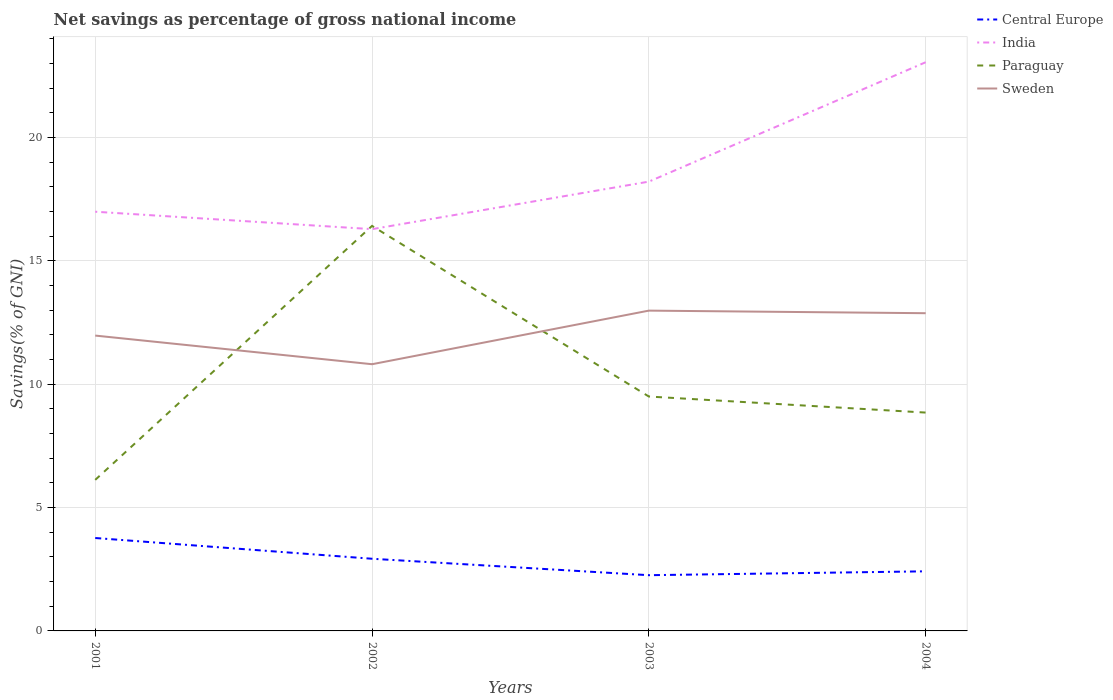How many different coloured lines are there?
Your answer should be very brief. 4. Is the number of lines equal to the number of legend labels?
Offer a terse response. Yes. Across all years, what is the maximum total savings in Sweden?
Offer a very short reply. 10.81. In which year was the total savings in Paraguay maximum?
Make the answer very short. 2001. What is the total total savings in India in the graph?
Your answer should be very brief. -6.76. What is the difference between the highest and the second highest total savings in Paraguay?
Make the answer very short. 10.29. Is the total savings in India strictly greater than the total savings in Paraguay over the years?
Keep it short and to the point. No. How many lines are there?
Make the answer very short. 4. How many years are there in the graph?
Keep it short and to the point. 4. How are the legend labels stacked?
Provide a short and direct response. Vertical. What is the title of the graph?
Offer a very short reply. Net savings as percentage of gross national income. What is the label or title of the X-axis?
Offer a terse response. Years. What is the label or title of the Y-axis?
Offer a very short reply. Savings(% of GNI). What is the Savings(% of GNI) of Central Europe in 2001?
Make the answer very short. 3.77. What is the Savings(% of GNI) in India in 2001?
Give a very brief answer. 16.99. What is the Savings(% of GNI) in Paraguay in 2001?
Provide a short and direct response. 6.12. What is the Savings(% of GNI) of Sweden in 2001?
Give a very brief answer. 11.97. What is the Savings(% of GNI) in Central Europe in 2002?
Provide a short and direct response. 2.92. What is the Savings(% of GNI) in India in 2002?
Your answer should be compact. 16.28. What is the Savings(% of GNI) of Paraguay in 2002?
Make the answer very short. 16.41. What is the Savings(% of GNI) of Sweden in 2002?
Your answer should be very brief. 10.81. What is the Savings(% of GNI) of Central Europe in 2003?
Provide a short and direct response. 2.26. What is the Savings(% of GNI) of India in 2003?
Provide a short and direct response. 18.21. What is the Savings(% of GNI) in Paraguay in 2003?
Keep it short and to the point. 9.5. What is the Savings(% of GNI) in Sweden in 2003?
Offer a terse response. 12.98. What is the Savings(% of GNI) in Central Europe in 2004?
Provide a succinct answer. 2.42. What is the Savings(% of GNI) of India in 2004?
Offer a terse response. 23.04. What is the Savings(% of GNI) of Paraguay in 2004?
Your response must be concise. 8.85. What is the Savings(% of GNI) in Sweden in 2004?
Keep it short and to the point. 12.87. Across all years, what is the maximum Savings(% of GNI) in Central Europe?
Provide a succinct answer. 3.77. Across all years, what is the maximum Savings(% of GNI) of India?
Make the answer very short. 23.04. Across all years, what is the maximum Savings(% of GNI) of Paraguay?
Provide a short and direct response. 16.41. Across all years, what is the maximum Savings(% of GNI) of Sweden?
Provide a short and direct response. 12.98. Across all years, what is the minimum Savings(% of GNI) in Central Europe?
Your response must be concise. 2.26. Across all years, what is the minimum Savings(% of GNI) of India?
Make the answer very short. 16.28. Across all years, what is the minimum Savings(% of GNI) in Paraguay?
Your response must be concise. 6.12. Across all years, what is the minimum Savings(% of GNI) in Sweden?
Ensure brevity in your answer.  10.81. What is the total Savings(% of GNI) of Central Europe in the graph?
Offer a very short reply. 11.36. What is the total Savings(% of GNI) in India in the graph?
Your answer should be compact. 74.52. What is the total Savings(% of GNI) in Paraguay in the graph?
Your answer should be very brief. 40.88. What is the total Savings(% of GNI) in Sweden in the graph?
Offer a terse response. 48.63. What is the difference between the Savings(% of GNI) of Central Europe in 2001 and that in 2002?
Ensure brevity in your answer.  0.84. What is the difference between the Savings(% of GNI) in India in 2001 and that in 2002?
Provide a short and direct response. 0.71. What is the difference between the Savings(% of GNI) of Paraguay in 2001 and that in 2002?
Provide a succinct answer. -10.29. What is the difference between the Savings(% of GNI) in Sweden in 2001 and that in 2002?
Keep it short and to the point. 1.16. What is the difference between the Savings(% of GNI) in Central Europe in 2001 and that in 2003?
Your response must be concise. 1.51. What is the difference between the Savings(% of GNI) in India in 2001 and that in 2003?
Provide a succinct answer. -1.22. What is the difference between the Savings(% of GNI) of Paraguay in 2001 and that in 2003?
Offer a very short reply. -3.38. What is the difference between the Savings(% of GNI) of Sweden in 2001 and that in 2003?
Your answer should be compact. -1.01. What is the difference between the Savings(% of GNI) in Central Europe in 2001 and that in 2004?
Give a very brief answer. 1.35. What is the difference between the Savings(% of GNI) in India in 2001 and that in 2004?
Make the answer very short. -6.06. What is the difference between the Savings(% of GNI) of Paraguay in 2001 and that in 2004?
Provide a succinct answer. -2.73. What is the difference between the Savings(% of GNI) in Sweden in 2001 and that in 2004?
Make the answer very short. -0.91. What is the difference between the Savings(% of GNI) in Central Europe in 2002 and that in 2003?
Keep it short and to the point. 0.67. What is the difference between the Savings(% of GNI) of India in 2002 and that in 2003?
Your response must be concise. -1.93. What is the difference between the Savings(% of GNI) in Paraguay in 2002 and that in 2003?
Offer a terse response. 6.91. What is the difference between the Savings(% of GNI) in Sweden in 2002 and that in 2003?
Provide a short and direct response. -2.17. What is the difference between the Savings(% of GNI) in Central Europe in 2002 and that in 2004?
Provide a succinct answer. 0.51. What is the difference between the Savings(% of GNI) in India in 2002 and that in 2004?
Give a very brief answer. -6.76. What is the difference between the Savings(% of GNI) of Paraguay in 2002 and that in 2004?
Make the answer very short. 7.56. What is the difference between the Savings(% of GNI) of Sweden in 2002 and that in 2004?
Offer a very short reply. -2.07. What is the difference between the Savings(% of GNI) in Central Europe in 2003 and that in 2004?
Your response must be concise. -0.16. What is the difference between the Savings(% of GNI) in India in 2003 and that in 2004?
Offer a very short reply. -4.84. What is the difference between the Savings(% of GNI) of Paraguay in 2003 and that in 2004?
Offer a terse response. 0.65. What is the difference between the Savings(% of GNI) in Sweden in 2003 and that in 2004?
Your answer should be very brief. 0.1. What is the difference between the Savings(% of GNI) in Central Europe in 2001 and the Savings(% of GNI) in India in 2002?
Ensure brevity in your answer.  -12.52. What is the difference between the Savings(% of GNI) in Central Europe in 2001 and the Savings(% of GNI) in Paraguay in 2002?
Your response must be concise. -12.65. What is the difference between the Savings(% of GNI) of Central Europe in 2001 and the Savings(% of GNI) of Sweden in 2002?
Keep it short and to the point. -7.04. What is the difference between the Savings(% of GNI) in India in 2001 and the Savings(% of GNI) in Paraguay in 2002?
Ensure brevity in your answer.  0.57. What is the difference between the Savings(% of GNI) of India in 2001 and the Savings(% of GNI) of Sweden in 2002?
Make the answer very short. 6.18. What is the difference between the Savings(% of GNI) in Paraguay in 2001 and the Savings(% of GNI) in Sweden in 2002?
Your answer should be compact. -4.69. What is the difference between the Savings(% of GNI) of Central Europe in 2001 and the Savings(% of GNI) of India in 2003?
Offer a very short reply. -14.44. What is the difference between the Savings(% of GNI) of Central Europe in 2001 and the Savings(% of GNI) of Paraguay in 2003?
Offer a terse response. -5.73. What is the difference between the Savings(% of GNI) in Central Europe in 2001 and the Savings(% of GNI) in Sweden in 2003?
Provide a succinct answer. -9.21. What is the difference between the Savings(% of GNI) in India in 2001 and the Savings(% of GNI) in Paraguay in 2003?
Ensure brevity in your answer.  7.49. What is the difference between the Savings(% of GNI) in India in 2001 and the Savings(% of GNI) in Sweden in 2003?
Give a very brief answer. 4.01. What is the difference between the Savings(% of GNI) of Paraguay in 2001 and the Savings(% of GNI) of Sweden in 2003?
Offer a terse response. -6.86. What is the difference between the Savings(% of GNI) in Central Europe in 2001 and the Savings(% of GNI) in India in 2004?
Your answer should be very brief. -19.28. What is the difference between the Savings(% of GNI) in Central Europe in 2001 and the Savings(% of GNI) in Paraguay in 2004?
Provide a short and direct response. -5.08. What is the difference between the Savings(% of GNI) of Central Europe in 2001 and the Savings(% of GNI) of Sweden in 2004?
Provide a short and direct response. -9.11. What is the difference between the Savings(% of GNI) in India in 2001 and the Savings(% of GNI) in Paraguay in 2004?
Keep it short and to the point. 8.14. What is the difference between the Savings(% of GNI) in India in 2001 and the Savings(% of GNI) in Sweden in 2004?
Ensure brevity in your answer.  4.11. What is the difference between the Savings(% of GNI) of Paraguay in 2001 and the Savings(% of GNI) of Sweden in 2004?
Offer a very short reply. -6.75. What is the difference between the Savings(% of GNI) in Central Europe in 2002 and the Savings(% of GNI) in India in 2003?
Ensure brevity in your answer.  -15.28. What is the difference between the Savings(% of GNI) in Central Europe in 2002 and the Savings(% of GNI) in Paraguay in 2003?
Keep it short and to the point. -6.57. What is the difference between the Savings(% of GNI) in Central Europe in 2002 and the Savings(% of GNI) in Sweden in 2003?
Keep it short and to the point. -10.05. What is the difference between the Savings(% of GNI) of India in 2002 and the Savings(% of GNI) of Paraguay in 2003?
Provide a succinct answer. 6.78. What is the difference between the Savings(% of GNI) of India in 2002 and the Savings(% of GNI) of Sweden in 2003?
Provide a short and direct response. 3.3. What is the difference between the Savings(% of GNI) of Paraguay in 2002 and the Savings(% of GNI) of Sweden in 2003?
Provide a short and direct response. 3.43. What is the difference between the Savings(% of GNI) in Central Europe in 2002 and the Savings(% of GNI) in India in 2004?
Your answer should be very brief. -20.12. What is the difference between the Savings(% of GNI) in Central Europe in 2002 and the Savings(% of GNI) in Paraguay in 2004?
Offer a very short reply. -5.92. What is the difference between the Savings(% of GNI) of Central Europe in 2002 and the Savings(% of GNI) of Sweden in 2004?
Offer a very short reply. -9.95. What is the difference between the Savings(% of GNI) in India in 2002 and the Savings(% of GNI) in Paraguay in 2004?
Your response must be concise. 7.43. What is the difference between the Savings(% of GNI) in India in 2002 and the Savings(% of GNI) in Sweden in 2004?
Your response must be concise. 3.41. What is the difference between the Savings(% of GNI) of Paraguay in 2002 and the Savings(% of GNI) of Sweden in 2004?
Ensure brevity in your answer.  3.54. What is the difference between the Savings(% of GNI) of Central Europe in 2003 and the Savings(% of GNI) of India in 2004?
Keep it short and to the point. -20.79. What is the difference between the Savings(% of GNI) of Central Europe in 2003 and the Savings(% of GNI) of Paraguay in 2004?
Offer a very short reply. -6.59. What is the difference between the Savings(% of GNI) in Central Europe in 2003 and the Savings(% of GNI) in Sweden in 2004?
Keep it short and to the point. -10.62. What is the difference between the Savings(% of GNI) in India in 2003 and the Savings(% of GNI) in Paraguay in 2004?
Provide a succinct answer. 9.36. What is the difference between the Savings(% of GNI) in India in 2003 and the Savings(% of GNI) in Sweden in 2004?
Give a very brief answer. 5.33. What is the difference between the Savings(% of GNI) in Paraguay in 2003 and the Savings(% of GNI) in Sweden in 2004?
Make the answer very short. -3.38. What is the average Savings(% of GNI) of Central Europe per year?
Offer a very short reply. 2.84. What is the average Savings(% of GNI) in India per year?
Keep it short and to the point. 18.63. What is the average Savings(% of GNI) in Paraguay per year?
Your answer should be very brief. 10.22. What is the average Savings(% of GNI) of Sweden per year?
Make the answer very short. 12.16. In the year 2001, what is the difference between the Savings(% of GNI) of Central Europe and Savings(% of GNI) of India?
Keep it short and to the point. -13.22. In the year 2001, what is the difference between the Savings(% of GNI) in Central Europe and Savings(% of GNI) in Paraguay?
Your response must be concise. -2.36. In the year 2001, what is the difference between the Savings(% of GNI) of Central Europe and Savings(% of GNI) of Sweden?
Ensure brevity in your answer.  -8.2. In the year 2001, what is the difference between the Savings(% of GNI) in India and Savings(% of GNI) in Paraguay?
Ensure brevity in your answer.  10.87. In the year 2001, what is the difference between the Savings(% of GNI) of India and Savings(% of GNI) of Sweden?
Ensure brevity in your answer.  5.02. In the year 2001, what is the difference between the Savings(% of GNI) of Paraguay and Savings(% of GNI) of Sweden?
Provide a succinct answer. -5.85. In the year 2002, what is the difference between the Savings(% of GNI) in Central Europe and Savings(% of GNI) in India?
Your answer should be very brief. -13.36. In the year 2002, what is the difference between the Savings(% of GNI) in Central Europe and Savings(% of GNI) in Paraguay?
Keep it short and to the point. -13.49. In the year 2002, what is the difference between the Savings(% of GNI) of Central Europe and Savings(% of GNI) of Sweden?
Keep it short and to the point. -7.88. In the year 2002, what is the difference between the Savings(% of GNI) of India and Savings(% of GNI) of Paraguay?
Your response must be concise. -0.13. In the year 2002, what is the difference between the Savings(% of GNI) of India and Savings(% of GNI) of Sweden?
Offer a very short reply. 5.47. In the year 2002, what is the difference between the Savings(% of GNI) of Paraguay and Savings(% of GNI) of Sweden?
Offer a very short reply. 5.61. In the year 2003, what is the difference between the Savings(% of GNI) in Central Europe and Savings(% of GNI) in India?
Offer a terse response. -15.95. In the year 2003, what is the difference between the Savings(% of GNI) of Central Europe and Savings(% of GNI) of Paraguay?
Provide a short and direct response. -7.24. In the year 2003, what is the difference between the Savings(% of GNI) of Central Europe and Savings(% of GNI) of Sweden?
Give a very brief answer. -10.72. In the year 2003, what is the difference between the Savings(% of GNI) of India and Savings(% of GNI) of Paraguay?
Your answer should be very brief. 8.71. In the year 2003, what is the difference between the Savings(% of GNI) of India and Savings(% of GNI) of Sweden?
Make the answer very short. 5.23. In the year 2003, what is the difference between the Savings(% of GNI) of Paraguay and Savings(% of GNI) of Sweden?
Provide a short and direct response. -3.48. In the year 2004, what is the difference between the Savings(% of GNI) in Central Europe and Savings(% of GNI) in India?
Make the answer very short. -20.63. In the year 2004, what is the difference between the Savings(% of GNI) of Central Europe and Savings(% of GNI) of Paraguay?
Give a very brief answer. -6.43. In the year 2004, what is the difference between the Savings(% of GNI) in Central Europe and Savings(% of GNI) in Sweden?
Your response must be concise. -10.46. In the year 2004, what is the difference between the Savings(% of GNI) of India and Savings(% of GNI) of Paraguay?
Give a very brief answer. 14.2. In the year 2004, what is the difference between the Savings(% of GNI) in India and Savings(% of GNI) in Sweden?
Give a very brief answer. 10.17. In the year 2004, what is the difference between the Savings(% of GNI) in Paraguay and Savings(% of GNI) in Sweden?
Provide a succinct answer. -4.03. What is the ratio of the Savings(% of GNI) of Central Europe in 2001 to that in 2002?
Your answer should be very brief. 1.29. What is the ratio of the Savings(% of GNI) of India in 2001 to that in 2002?
Provide a short and direct response. 1.04. What is the ratio of the Savings(% of GNI) in Paraguay in 2001 to that in 2002?
Provide a short and direct response. 0.37. What is the ratio of the Savings(% of GNI) of Sweden in 2001 to that in 2002?
Your response must be concise. 1.11. What is the ratio of the Savings(% of GNI) in Central Europe in 2001 to that in 2003?
Ensure brevity in your answer.  1.67. What is the ratio of the Savings(% of GNI) in India in 2001 to that in 2003?
Your answer should be very brief. 0.93. What is the ratio of the Savings(% of GNI) of Paraguay in 2001 to that in 2003?
Keep it short and to the point. 0.64. What is the ratio of the Savings(% of GNI) of Sweden in 2001 to that in 2003?
Ensure brevity in your answer.  0.92. What is the ratio of the Savings(% of GNI) of Central Europe in 2001 to that in 2004?
Your response must be concise. 1.56. What is the ratio of the Savings(% of GNI) in India in 2001 to that in 2004?
Give a very brief answer. 0.74. What is the ratio of the Savings(% of GNI) in Paraguay in 2001 to that in 2004?
Your answer should be compact. 0.69. What is the ratio of the Savings(% of GNI) in Sweden in 2001 to that in 2004?
Keep it short and to the point. 0.93. What is the ratio of the Savings(% of GNI) of Central Europe in 2002 to that in 2003?
Make the answer very short. 1.29. What is the ratio of the Savings(% of GNI) in India in 2002 to that in 2003?
Offer a terse response. 0.89. What is the ratio of the Savings(% of GNI) in Paraguay in 2002 to that in 2003?
Give a very brief answer. 1.73. What is the ratio of the Savings(% of GNI) in Sweden in 2002 to that in 2003?
Make the answer very short. 0.83. What is the ratio of the Savings(% of GNI) in Central Europe in 2002 to that in 2004?
Your response must be concise. 1.21. What is the ratio of the Savings(% of GNI) of India in 2002 to that in 2004?
Provide a short and direct response. 0.71. What is the ratio of the Savings(% of GNI) of Paraguay in 2002 to that in 2004?
Ensure brevity in your answer.  1.85. What is the ratio of the Savings(% of GNI) of Sweden in 2002 to that in 2004?
Offer a very short reply. 0.84. What is the ratio of the Savings(% of GNI) of Central Europe in 2003 to that in 2004?
Provide a short and direct response. 0.94. What is the ratio of the Savings(% of GNI) of India in 2003 to that in 2004?
Offer a terse response. 0.79. What is the ratio of the Savings(% of GNI) of Paraguay in 2003 to that in 2004?
Your response must be concise. 1.07. What is the difference between the highest and the second highest Savings(% of GNI) in Central Europe?
Your answer should be very brief. 0.84. What is the difference between the highest and the second highest Savings(% of GNI) of India?
Your answer should be compact. 4.84. What is the difference between the highest and the second highest Savings(% of GNI) in Paraguay?
Offer a very short reply. 6.91. What is the difference between the highest and the second highest Savings(% of GNI) of Sweden?
Ensure brevity in your answer.  0.1. What is the difference between the highest and the lowest Savings(% of GNI) of Central Europe?
Your answer should be very brief. 1.51. What is the difference between the highest and the lowest Savings(% of GNI) of India?
Keep it short and to the point. 6.76. What is the difference between the highest and the lowest Savings(% of GNI) in Paraguay?
Provide a succinct answer. 10.29. What is the difference between the highest and the lowest Savings(% of GNI) in Sweden?
Offer a terse response. 2.17. 